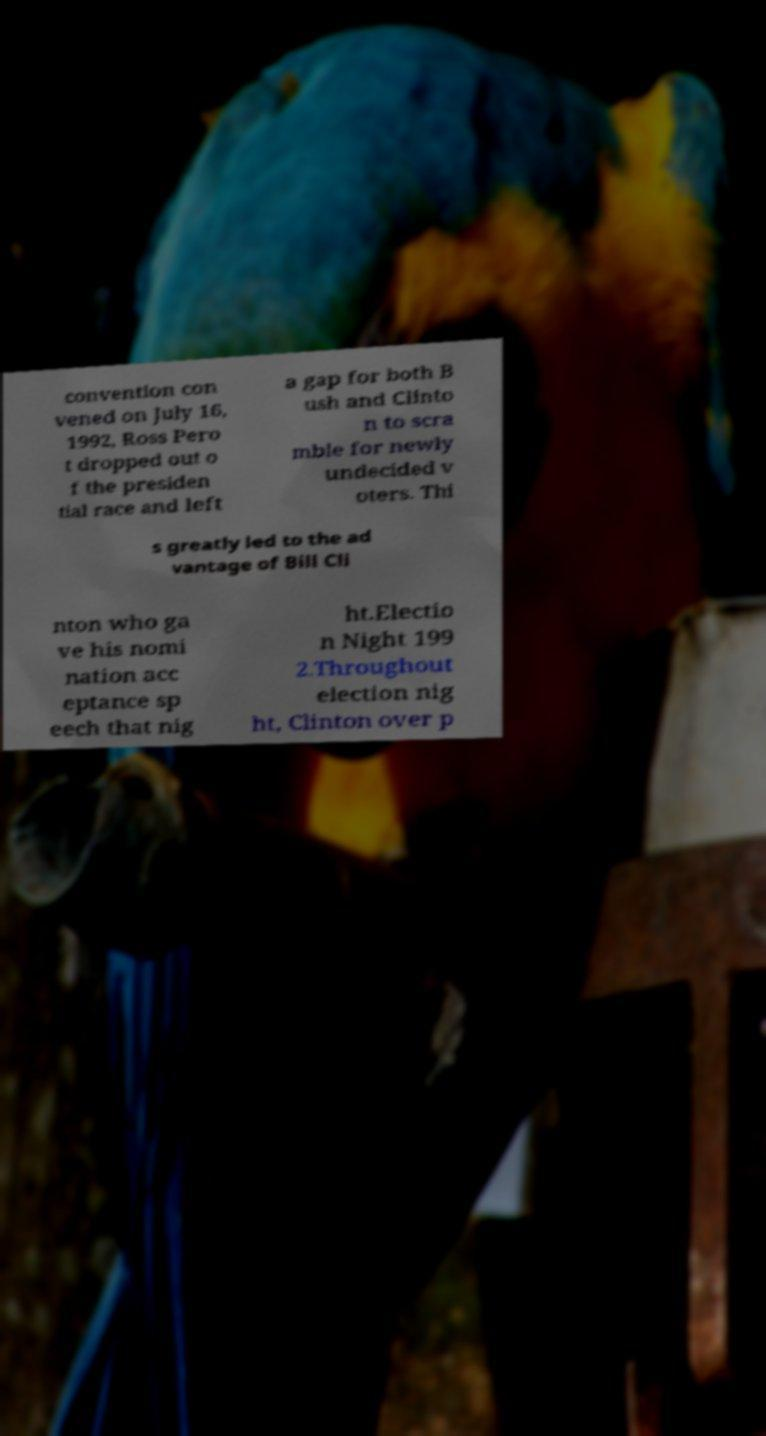Please identify and transcribe the text found in this image. convention con vened on July 16, 1992, Ross Pero t dropped out o f the presiden tial race and left a gap for both B ush and Clinto n to scra mble for newly undecided v oters. Thi s greatly led to the ad vantage of Bill Cli nton who ga ve his nomi nation acc eptance sp eech that nig ht.Electio n Night 199 2.Throughout election nig ht, Clinton over p 